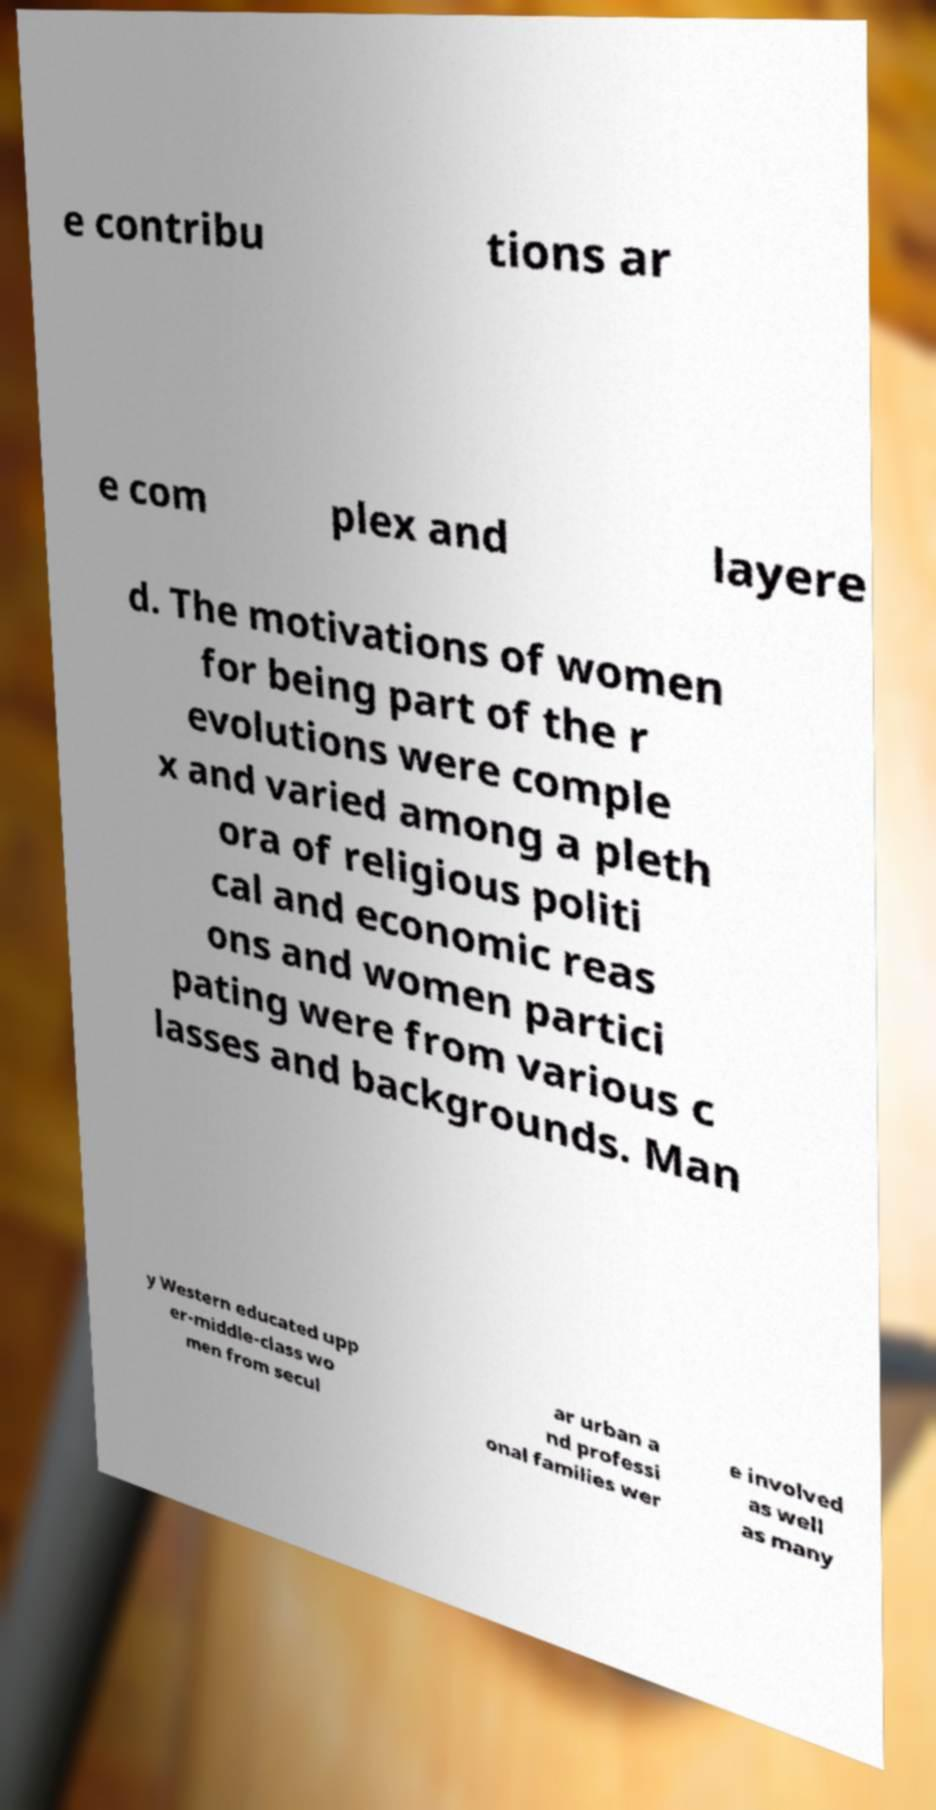Can you accurately transcribe the text from the provided image for me? e contribu tions ar e com plex and layere d. The motivations of women for being part of the r evolutions were comple x and varied among a pleth ora of religious politi cal and economic reas ons and women partici pating were from various c lasses and backgrounds. Man y Western educated upp er-middle-class wo men from secul ar urban a nd professi onal families wer e involved as well as many 